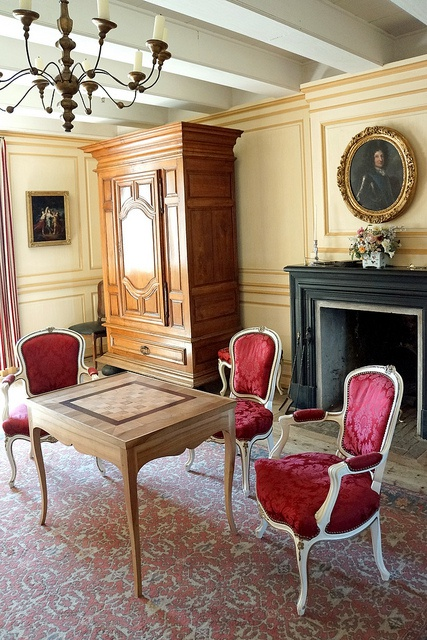Describe the objects in this image and their specific colors. I can see chair in beige, maroon, darkgray, brown, and black tones, dining table in lightgray, tan, and maroon tones, chair in lightgray, maroon, brown, and salmon tones, chair in lightgray, maroon, white, brown, and darkgray tones, and potted plant in lightgray, olive, tan, gray, and black tones in this image. 